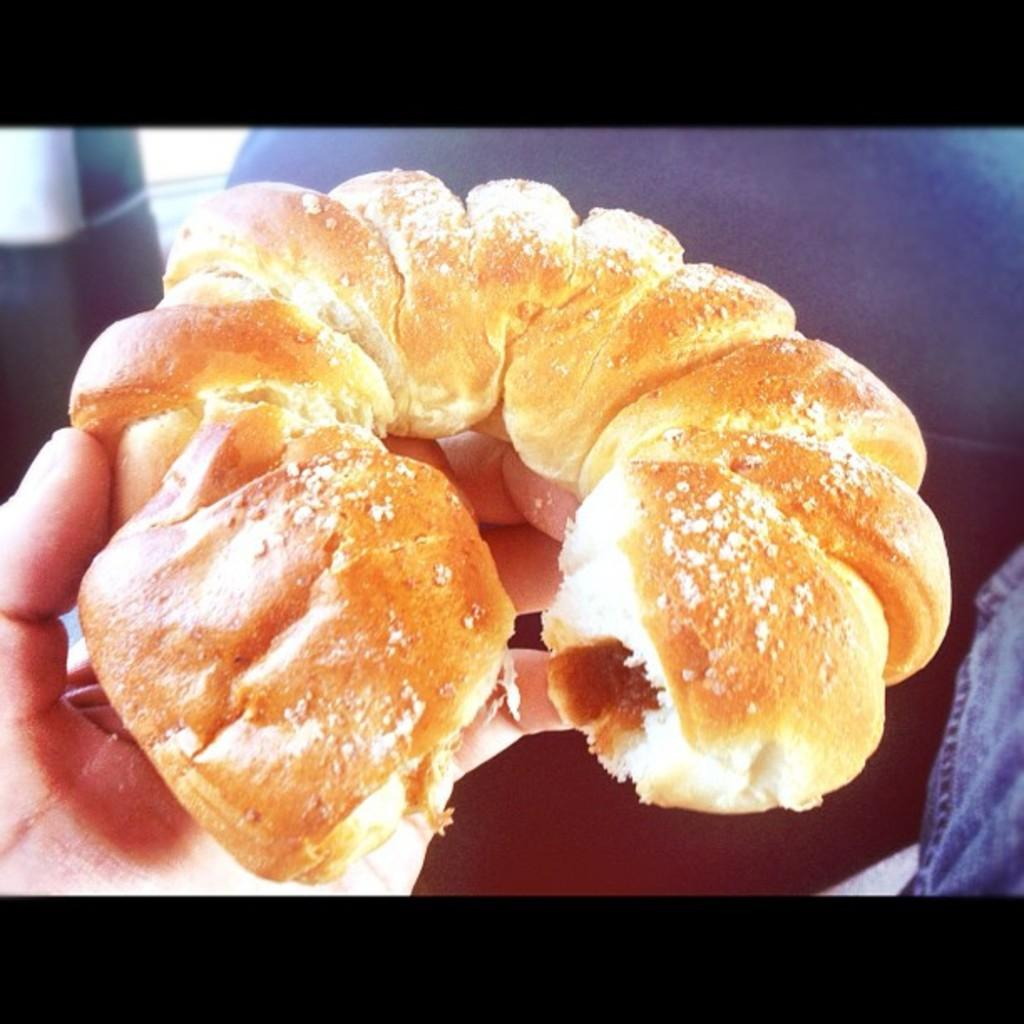What is the main subject of the image? The main subject of the image is a hand. What is the hand doing in the image? The hand is holding some food. What type of weather can be seen in the image? There is no weather visible in the image, as it only features a hand holding food. Is there a carriage present in the image? There is no carriage present in the image; it only features a hand holding food. 